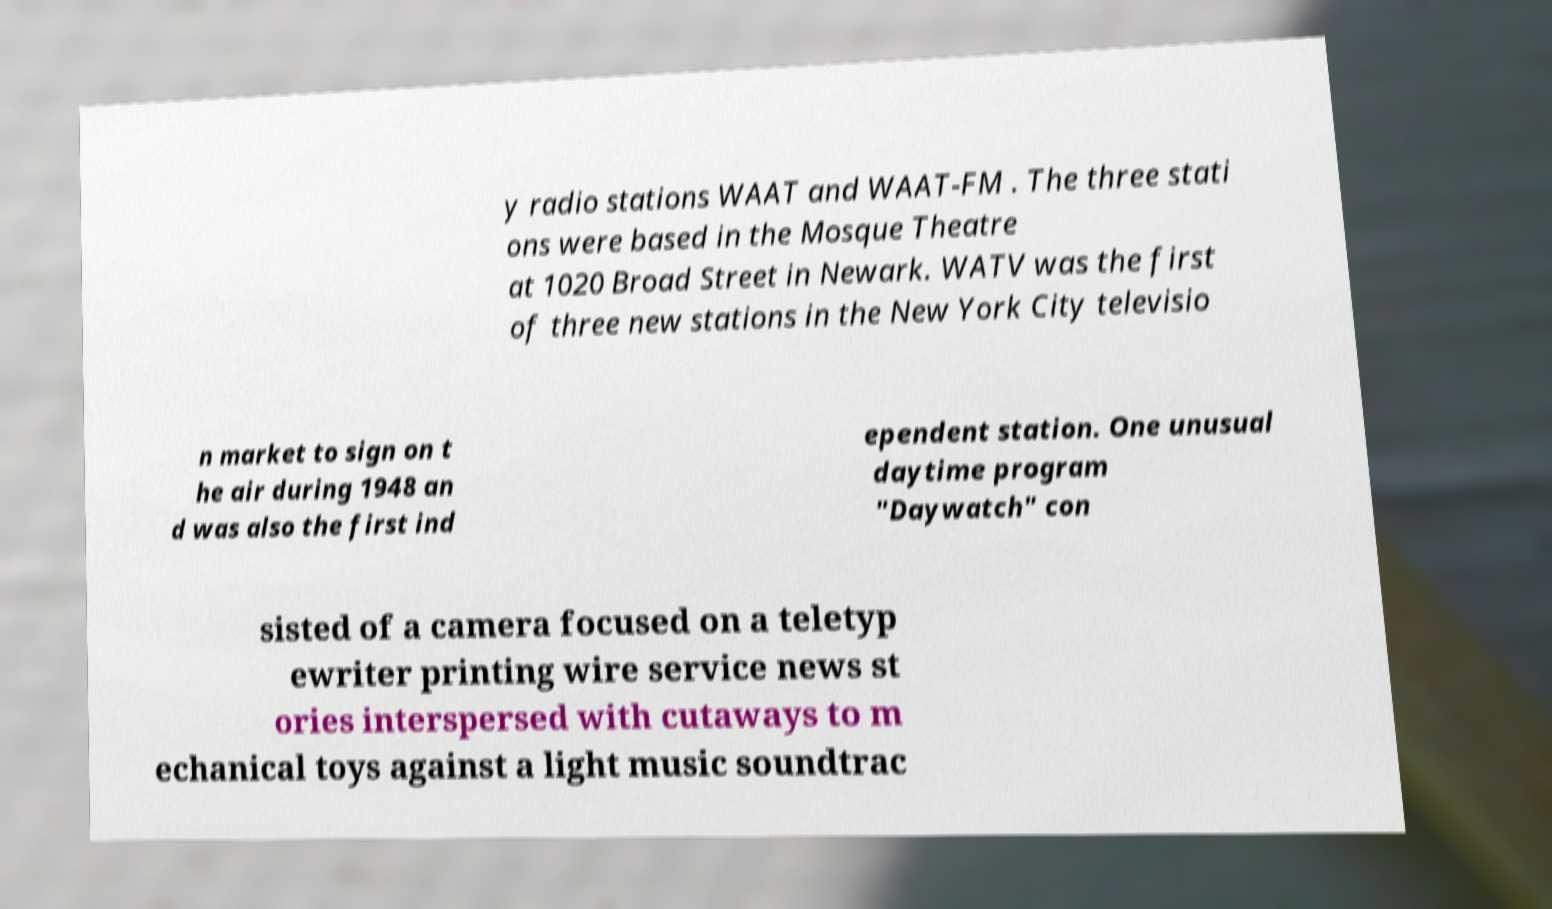Could you assist in decoding the text presented in this image and type it out clearly? y radio stations WAAT and WAAT-FM . The three stati ons were based in the Mosque Theatre at 1020 Broad Street in Newark. WATV was the first of three new stations in the New York City televisio n market to sign on t he air during 1948 an d was also the first ind ependent station. One unusual daytime program "Daywatch" con sisted of a camera focused on a teletyp ewriter printing wire service news st ories interspersed with cutaways to m echanical toys against a light music soundtrac 